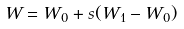<formula> <loc_0><loc_0><loc_500><loc_500>W = W _ { 0 } + s ( W _ { 1 } - W _ { 0 } )</formula> 